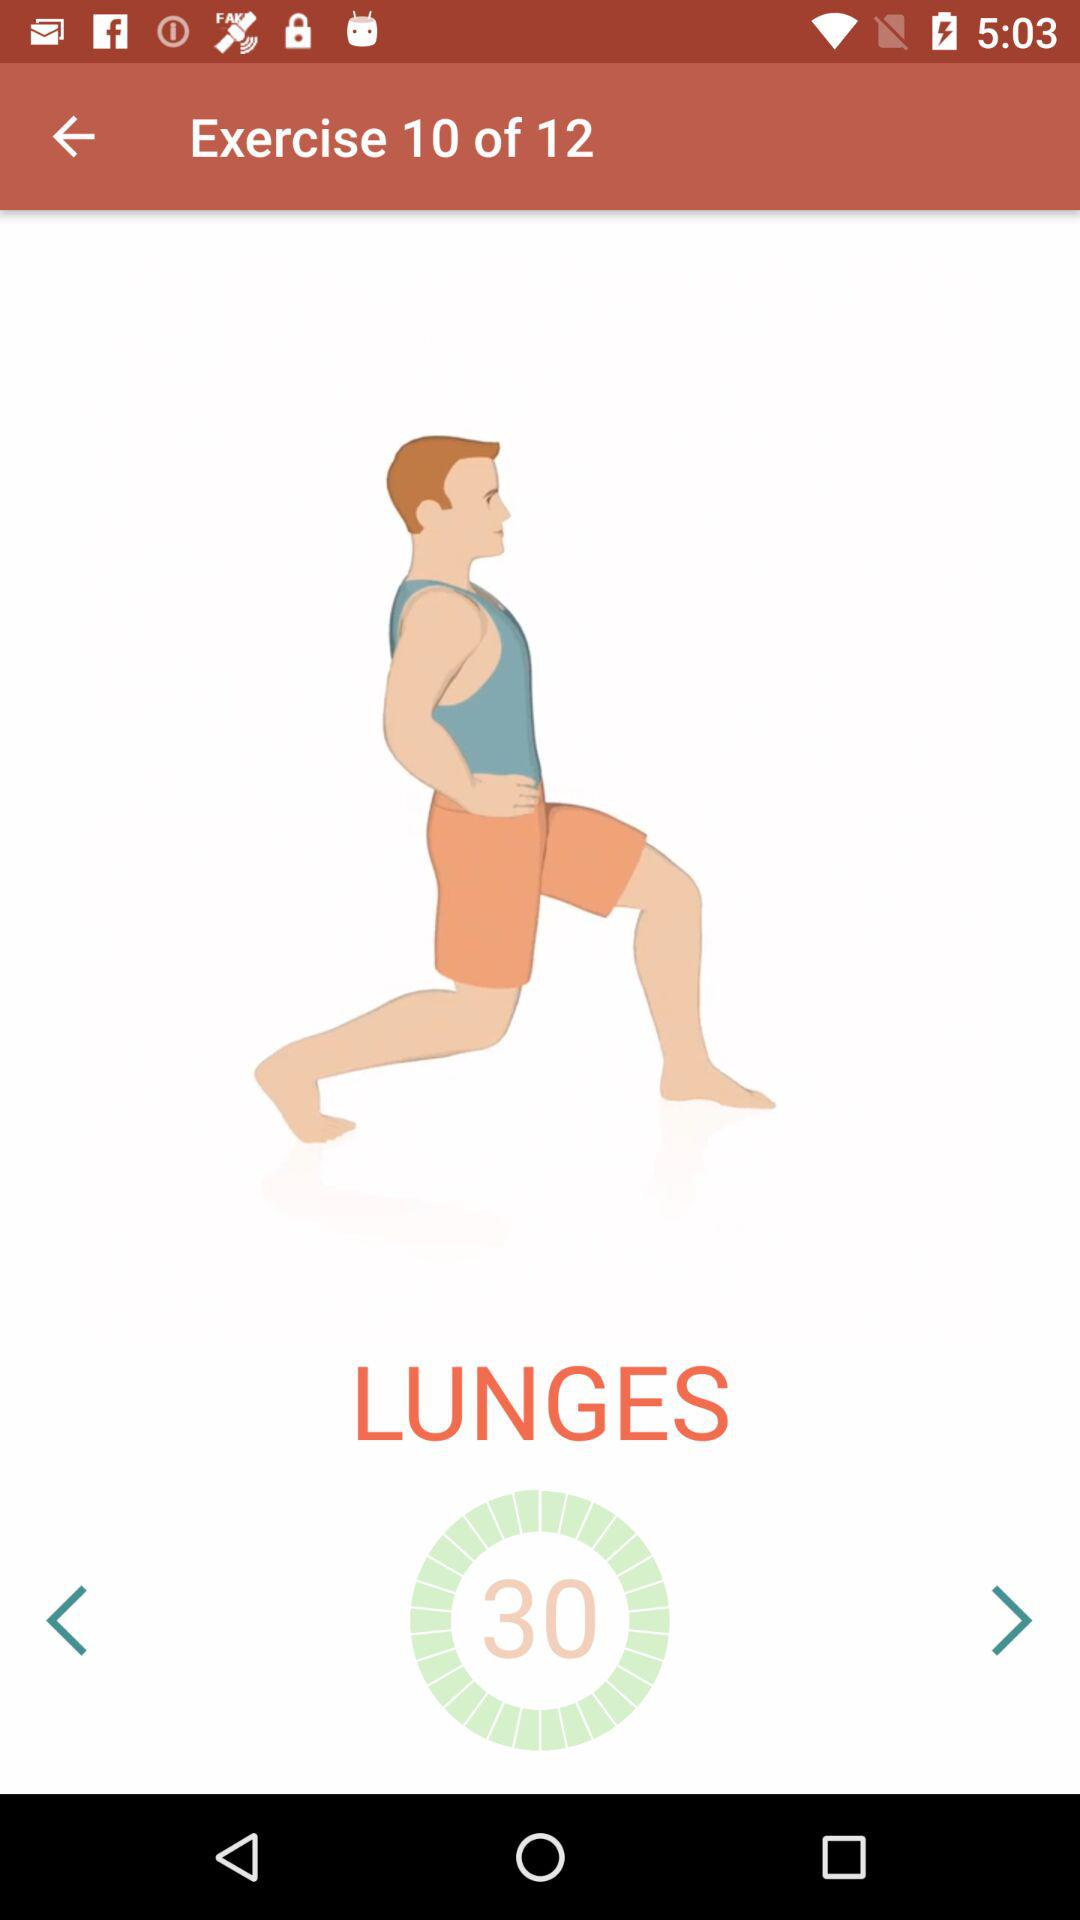How many exercises are there in the workout?
Answer the question using a single word or phrase. 12 